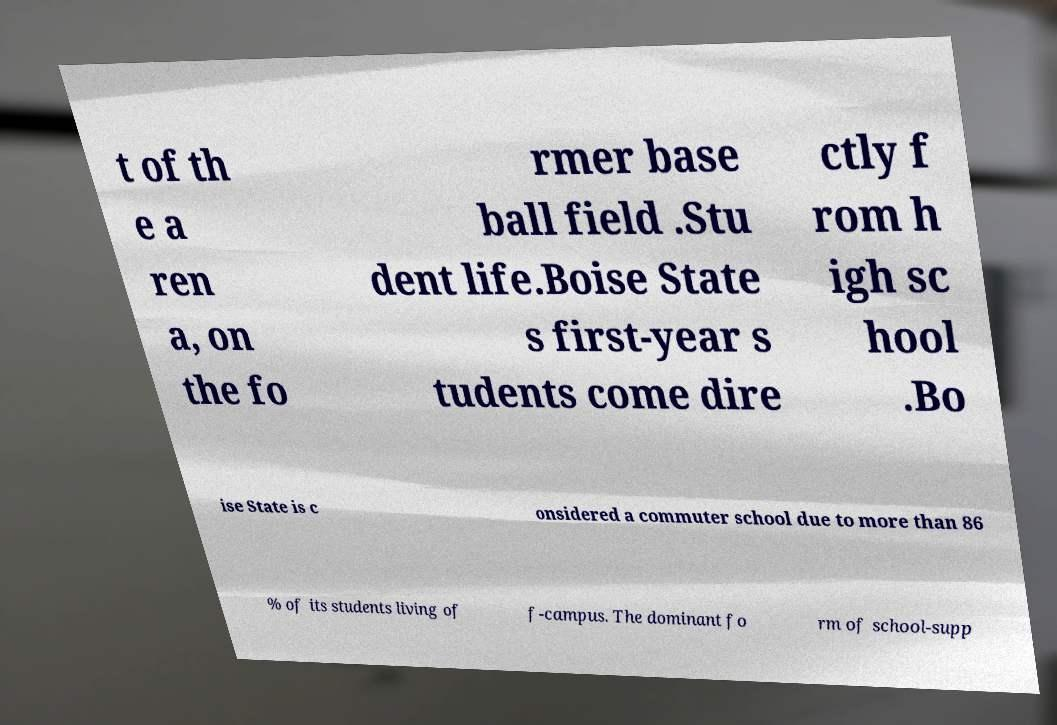Can you read and provide the text displayed in the image?This photo seems to have some interesting text. Can you extract and type it out for me? t of th e a ren a, on the fo rmer base ball field .Stu dent life.Boise State s first-year s tudents come dire ctly f rom h igh sc hool .Bo ise State is c onsidered a commuter school due to more than 86 % of its students living of f-campus. The dominant fo rm of school-supp 